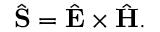Convert formula to latex. <formula><loc_0><loc_0><loc_500><loc_500>\begin{array} { r } { \hat { S } = \hat { E } \times \hat { H } . } \end{array}</formula> 